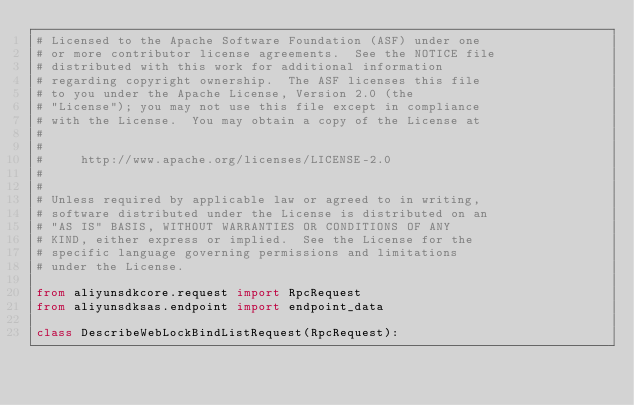<code> <loc_0><loc_0><loc_500><loc_500><_Python_># Licensed to the Apache Software Foundation (ASF) under one
# or more contributor license agreements.  See the NOTICE file
# distributed with this work for additional information
# regarding copyright ownership.  The ASF licenses this file
# to you under the Apache License, Version 2.0 (the
# "License"); you may not use this file except in compliance
# with the License.  You may obtain a copy of the License at
#
#
#     http://www.apache.org/licenses/LICENSE-2.0
#
#
# Unless required by applicable law or agreed to in writing,
# software distributed under the License is distributed on an
# "AS IS" BASIS, WITHOUT WARRANTIES OR CONDITIONS OF ANY
# KIND, either express or implied.  See the License for the
# specific language governing permissions and limitations
# under the License.

from aliyunsdkcore.request import RpcRequest
from aliyunsdksas.endpoint import endpoint_data

class DescribeWebLockBindListRequest(RpcRequest):
</code> 